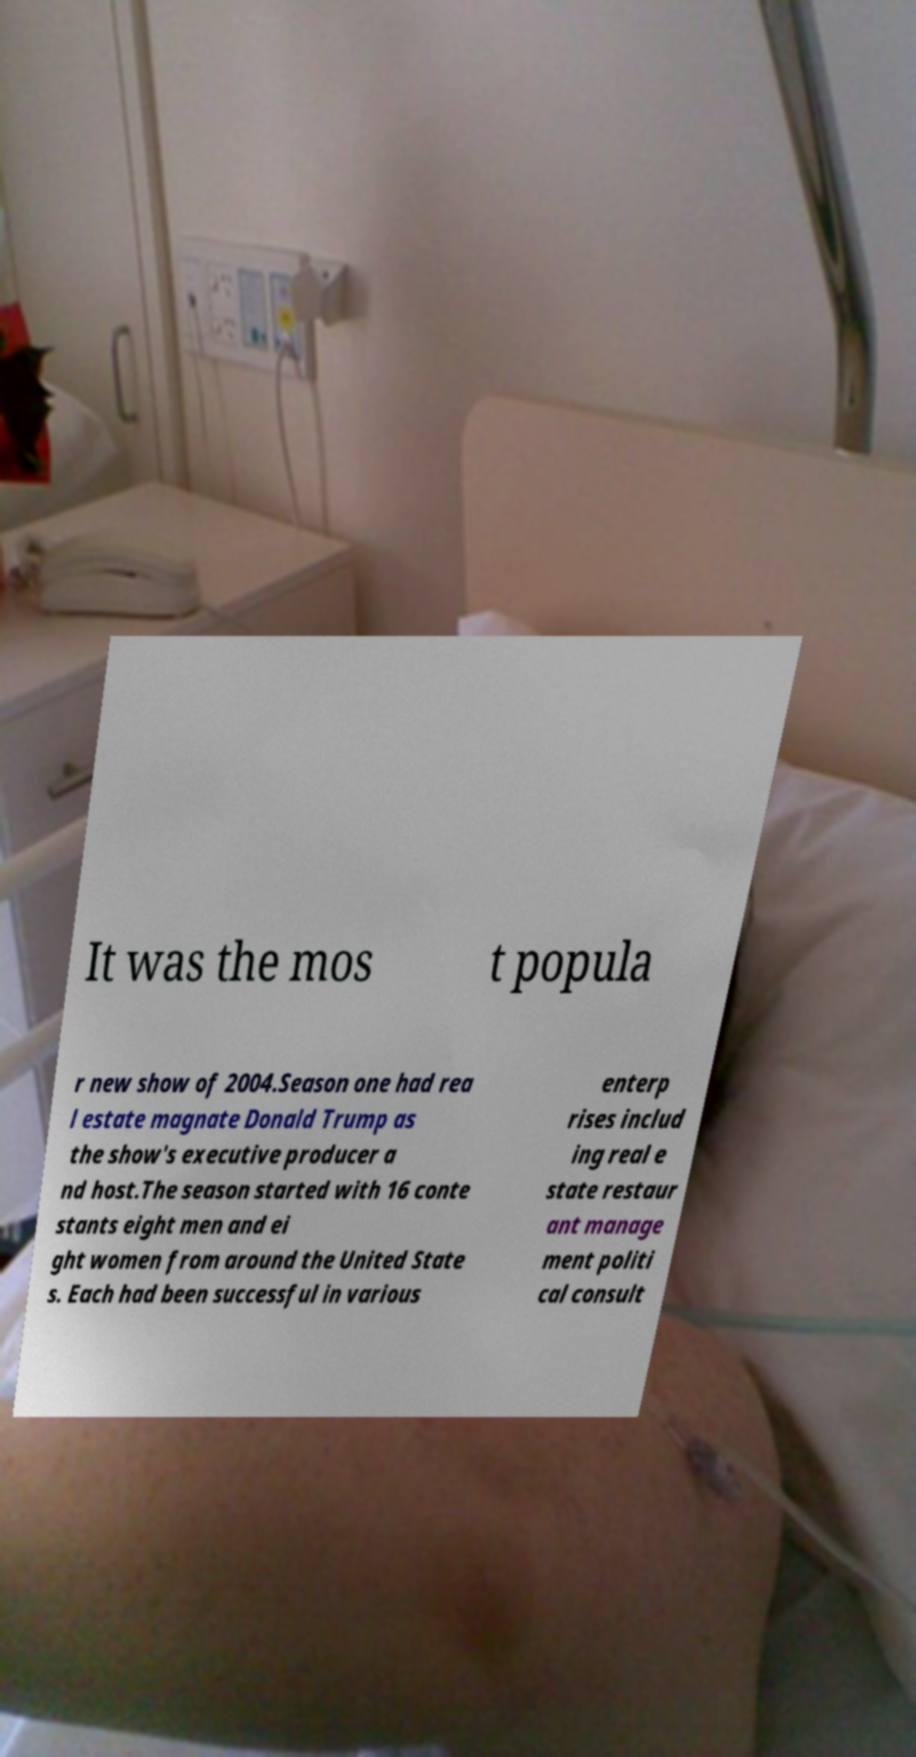There's text embedded in this image that I need extracted. Can you transcribe it verbatim? It was the mos t popula r new show of 2004.Season one had rea l estate magnate Donald Trump as the show's executive producer a nd host.The season started with 16 conte stants eight men and ei ght women from around the United State s. Each had been successful in various enterp rises includ ing real e state restaur ant manage ment politi cal consult 